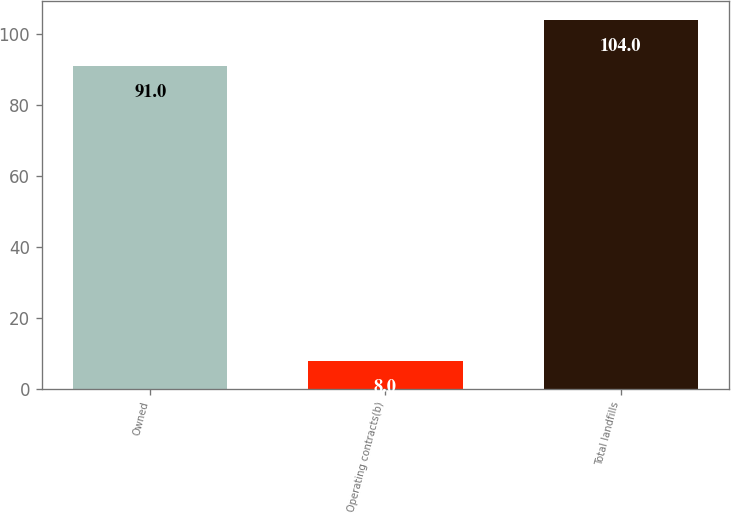Convert chart. <chart><loc_0><loc_0><loc_500><loc_500><bar_chart><fcel>Owned<fcel>Operating contracts(b)<fcel>Total landfills<nl><fcel>91<fcel>8<fcel>104<nl></chart> 